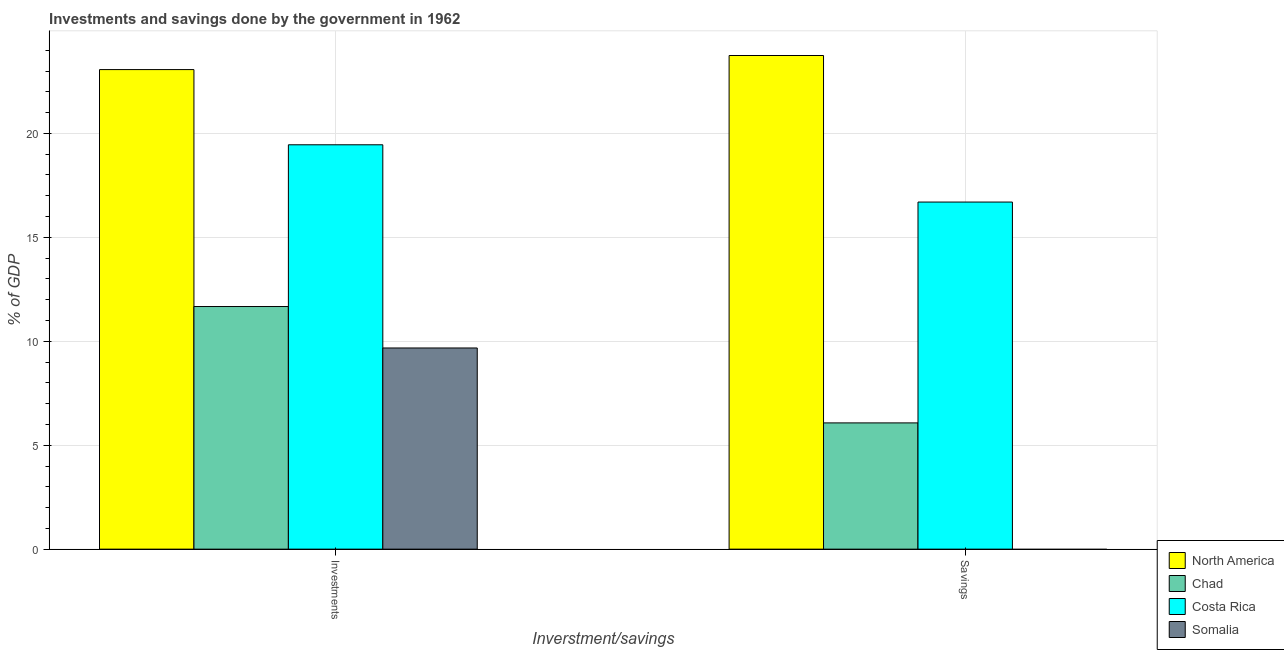How many bars are there on the 2nd tick from the left?
Provide a succinct answer. 3. What is the label of the 1st group of bars from the left?
Make the answer very short. Investments. Across all countries, what is the maximum savings of government?
Make the answer very short. 23.75. What is the total savings of government in the graph?
Provide a short and direct response. 46.52. What is the difference between the savings of government in North America and that in Costa Rica?
Give a very brief answer. 7.05. What is the difference between the savings of government in North America and the investments of government in Chad?
Offer a terse response. 12.08. What is the average savings of government per country?
Ensure brevity in your answer.  11.63. What is the difference between the savings of government and investments of government in Chad?
Offer a very short reply. -5.6. In how many countries, is the investments of government greater than 13 %?
Offer a very short reply. 2. What is the ratio of the savings of government in Chad to that in Costa Rica?
Your answer should be compact. 0.36. In how many countries, is the savings of government greater than the average savings of government taken over all countries?
Provide a succinct answer. 2. Are all the bars in the graph horizontal?
Your answer should be compact. No. How many countries are there in the graph?
Offer a terse response. 4. What is the difference between two consecutive major ticks on the Y-axis?
Your response must be concise. 5. Are the values on the major ticks of Y-axis written in scientific E-notation?
Offer a terse response. No. Where does the legend appear in the graph?
Provide a short and direct response. Bottom right. How many legend labels are there?
Give a very brief answer. 4. What is the title of the graph?
Offer a very short reply. Investments and savings done by the government in 1962. Does "Iran" appear as one of the legend labels in the graph?
Give a very brief answer. No. What is the label or title of the X-axis?
Offer a terse response. Inverstment/savings. What is the label or title of the Y-axis?
Provide a succinct answer. % of GDP. What is the % of GDP in North America in Investments?
Offer a terse response. 23.07. What is the % of GDP in Chad in Investments?
Your answer should be very brief. 11.67. What is the % of GDP of Costa Rica in Investments?
Offer a very short reply. 19.45. What is the % of GDP in Somalia in Investments?
Keep it short and to the point. 9.68. What is the % of GDP in North America in Savings?
Keep it short and to the point. 23.75. What is the % of GDP of Chad in Savings?
Make the answer very short. 6.07. What is the % of GDP of Costa Rica in Savings?
Provide a succinct answer. 16.7. Across all Inverstment/savings, what is the maximum % of GDP of North America?
Your answer should be compact. 23.75. Across all Inverstment/savings, what is the maximum % of GDP of Chad?
Offer a terse response. 11.67. Across all Inverstment/savings, what is the maximum % of GDP of Costa Rica?
Provide a succinct answer. 19.45. Across all Inverstment/savings, what is the maximum % of GDP of Somalia?
Provide a succinct answer. 9.68. Across all Inverstment/savings, what is the minimum % of GDP in North America?
Offer a very short reply. 23.07. Across all Inverstment/savings, what is the minimum % of GDP of Chad?
Offer a very short reply. 6.07. Across all Inverstment/savings, what is the minimum % of GDP of Costa Rica?
Ensure brevity in your answer.  16.7. What is the total % of GDP of North America in the graph?
Your answer should be compact. 46.82. What is the total % of GDP in Chad in the graph?
Offer a terse response. 17.75. What is the total % of GDP in Costa Rica in the graph?
Your response must be concise. 36.15. What is the total % of GDP of Somalia in the graph?
Your response must be concise. 9.68. What is the difference between the % of GDP in North America in Investments and that in Savings?
Your answer should be very brief. -0.68. What is the difference between the % of GDP in Chad in Investments and that in Savings?
Provide a short and direct response. 5.6. What is the difference between the % of GDP of Costa Rica in Investments and that in Savings?
Your answer should be compact. 2.76. What is the difference between the % of GDP in North America in Investments and the % of GDP in Chad in Savings?
Your answer should be very brief. 17. What is the difference between the % of GDP in North America in Investments and the % of GDP in Costa Rica in Savings?
Your response must be concise. 6.37. What is the difference between the % of GDP in Chad in Investments and the % of GDP in Costa Rica in Savings?
Make the answer very short. -5.03. What is the average % of GDP in North America per Inverstment/savings?
Give a very brief answer. 23.41. What is the average % of GDP of Chad per Inverstment/savings?
Offer a very short reply. 8.87. What is the average % of GDP of Costa Rica per Inverstment/savings?
Offer a very short reply. 18.08. What is the average % of GDP in Somalia per Inverstment/savings?
Offer a very short reply. 4.84. What is the difference between the % of GDP in North America and % of GDP in Chad in Investments?
Ensure brevity in your answer.  11.4. What is the difference between the % of GDP in North America and % of GDP in Costa Rica in Investments?
Your answer should be compact. 3.62. What is the difference between the % of GDP in North America and % of GDP in Somalia in Investments?
Provide a succinct answer. 13.39. What is the difference between the % of GDP in Chad and % of GDP in Costa Rica in Investments?
Provide a succinct answer. -7.78. What is the difference between the % of GDP of Chad and % of GDP of Somalia in Investments?
Make the answer very short. 1.99. What is the difference between the % of GDP of Costa Rica and % of GDP of Somalia in Investments?
Offer a terse response. 9.78. What is the difference between the % of GDP of North America and % of GDP of Chad in Savings?
Your answer should be compact. 17.67. What is the difference between the % of GDP in North America and % of GDP in Costa Rica in Savings?
Provide a short and direct response. 7.05. What is the difference between the % of GDP of Chad and % of GDP of Costa Rica in Savings?
Ensure brevity in your answer.  -10.62. What is the ratio of the % of GDP in North America in Investments to that in Savings?
Ensure brevity in your answer.  0.97. What is the ratio of the % of GDP of Chad in Investments to that in Savings?
Keep it short and to the point. 1.92. What is the ratio of the % of GDP in Costa Rica in Investments to that in Savings?
Your answer should be very brief. 1.17. What is the difference between the highest and the second highest % of GDP in North America?
Provide a succinct answer. 0.68. What is the difference between the highest and the second highest % of GDP in Chad?
Give a very brief answer. 5.6. What is the difference between the highest and the second highest % of GDP in Costa Rica?
Provide a succinct answer. 2.76. What is the difference between the highest and the lowest % of GDP in North America?
Give a very brief answer. 0.68. What is the difference between the highest and the lowest % of GDP in Chad?
Make the answer very short. 5.6. What is the difference between the highest and the lowest % of GDP in Costa Rica?
Keep it short and to the point. 2.76. What is the difference between the highest and the lowest % of GDP in Somalia?
Your answer should be very brief. 9.68. 